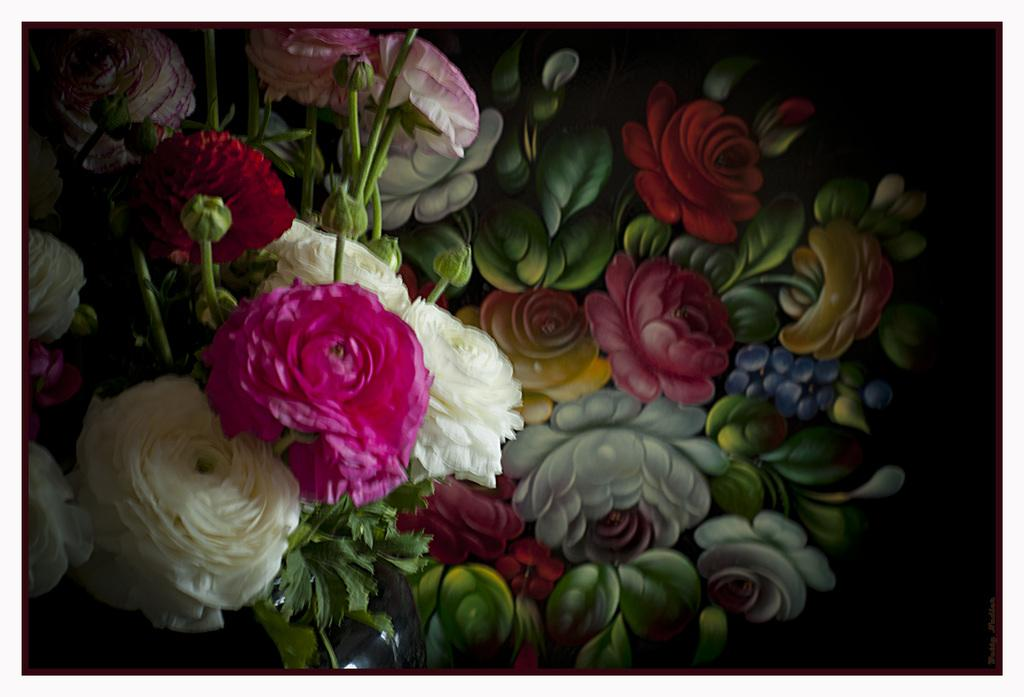What type of plants can be seen in the image? There are flowers in the image. What stage of growth are some of the plants in? There are buds in the image. What can be seen in the background of the image? There is a painting in the background of the image. What type of house is depicted in the painting in the background of the image? There is no house depicted in the painting in the background of the image. Can you tell me how many markets are visible in the image? There are no markets present in the image. 